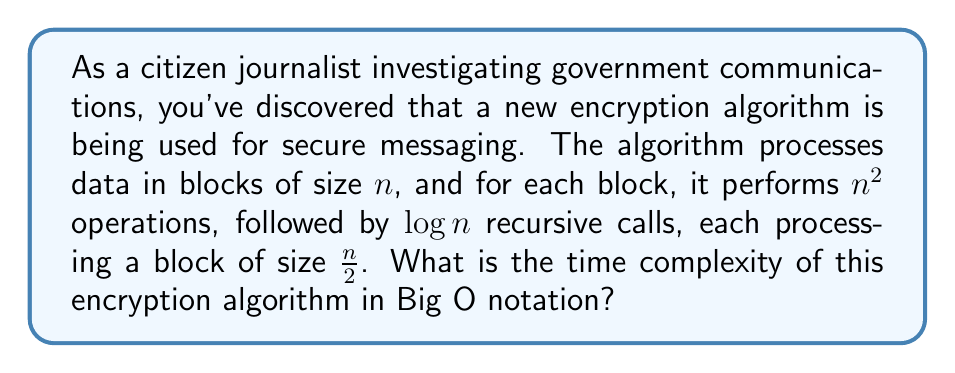Provide a solution to this math problem. Let's analyze this algorithm step-by-step:

1) For each block of size $n$, the algorithm performs:
   a) $n^2$ operations
   b) $\log n$ recursive calls on blocks of size $n/2$

2) Let $T(n)$ be the time complexity for a block of size $n$. We can write the recurrence relation:

   $$T(n) = n^2 + \log n \cdot T(n/2)$$

3) To solve this, let's use the Master Theorem. The general form is:
   
   $$T(n) = aT(n/b) + f(n)$$

   where $a = \log n$, $b = 2$, and $f(n) = n^2$

4) We need to compare $n^{\log_b a}$ with $f(n)$:
   
   $$n^{\log_b a} = n^{\log_2 (\log n)} = 2^{\log n \cdot \log \log n}$$

5) Clearly, $n^2$ grows faster than $2^{\log n \cdot \log \log n}$ for large $n$

6) This falls under case 3 of the Master Theorem: If $f(n) = \Omega(n^{\log_b a + \epsilon})$ for some $\epsilon > 0$, and if $af(n/b) \leq cf(n)$ for some $c < 1$ and all sufficiently large $n$, then $T(n) = \Theta(f(n))$

7) We can verify that $(\log n) \cdot (n/2)^2 \leq cn^2$ for $c < 1$ and large $n$

8) Therefore, $T(n) = \Theta(n^2)$

9) In Big O notation, we express this as $O(n^2)$
Answer: $O(n^2)$ 